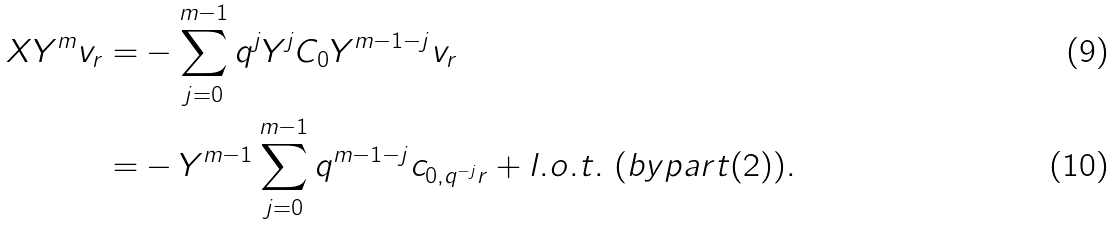<formula> <loc_0><loc_0><loc_500><loc_500>X Y ^ { m } v _ { r } = & - \sum _ { j = 0 } ^ { m - 1 } q ^ { j } Y ^ { j } C _ { 0 } Y ^ { m - 1 - j } v _ { r } \\ = & - Y ^ { m - 1 } \sum _ { j = 0 } ^ { m - 1 } q ^ { m - 1 - j } c _ { 0 , q ^ { - j } r } + l . o . t . \ ( b y p a r t ( 2 ) ) .</formula> 